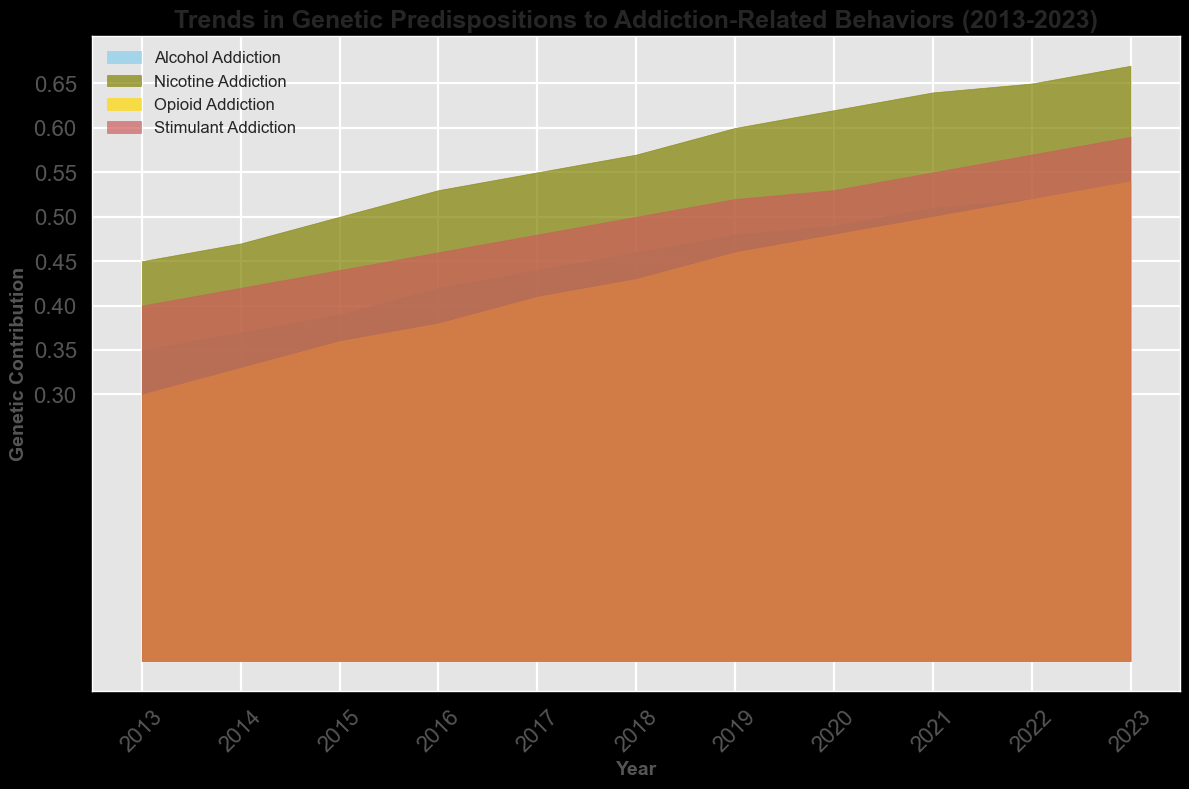What trend can be observed for the genetic contribution to alcohol addiction from 2013 to 2023? The genetic contribution to alcohol addiction shows a steady increase from 0.35 in 2013 to 0.54 in 2023.
Answer: Increasing trend How does the genetic contribution to nicotine addiction in 2023 compare to that in 2013? The genetic contribution to nicotine addiction in 2023 is 0.67, while in 2013 it was 0.45. This shows an increase of 0.22 over the decade.
Answer: 0.22 increase Which type of addiction showed the highest genetic contribution in 2023? The plot shows that in 2023, nicotine addiction has the highest genetic contribution, which is 0.67.
Answer: Nicotine addiction What is the average genetic contribution to opioid addiction across the entire period from 2013 to 2023? Sum the values from each year for opioid addiction (0.30 + 0.33 + 0.36 + 0.38 + 0.41 + 0.43 + 0.46 + 0.48 + 0.50 + 0.52 + 0.54) and divide by the number of years (11). The average is (4.71 / 11) ≈ 0.43.
Answer: 0.43 How much did the genetic contribution to stimulant addiction change from 2013 to 2018? The genetic contribution to stimulant addiction in 2013 was 0.40 and in 2018 it was 0.50. The change is 0.50 - 0.40 = 0.10.
Answer: 0.10 Between 2016 and 2019, which type of addiction showed the greatest increase in genetic contribution? Calculate the change for each type of addiction between 2016 and 2019: Alcohol (0.48 - 0.42 = 0.06), Nicotine (0.60 - 0.53 = 0.07), Opioid (0.46 - 0.38 = 0.08), Stimulant (0.52 - 0.46 = 0.06). The greatest increase is for opioid addiction with a change of 0.08.
Answer: Opioid addiction What is the overall trend in the genetic contribution to opioid addiction between 2015 and 2020? From 2015 to 2020, the genetic contribution to opioid addiction increases from 0.36 to 0.48, indicating an upward trend.
Answer: Increasing trend How does the genetic contribution to alcohol addiction in 2017 compare to stimulant addiction in the same year? In 2017, the genetic contribution to alcohol addiction is 0.44 while for stimulant addiction it is 0.48. Stimulant addiction has a slightly higher genetic contribution.
Answer: Stimulant addiction higher What is the median value of the genetic contribution to nicotine addiction from 2013 to 2023? Arrange the yearly values for nicotine addiction (0.45, 0.47, 0.50, 0.53, 0.55, 0.57, 0.60, 0.62, 0.64, 0.65, 0.67). The median is the middle value, which is 0.57.
Answer: 0.57 